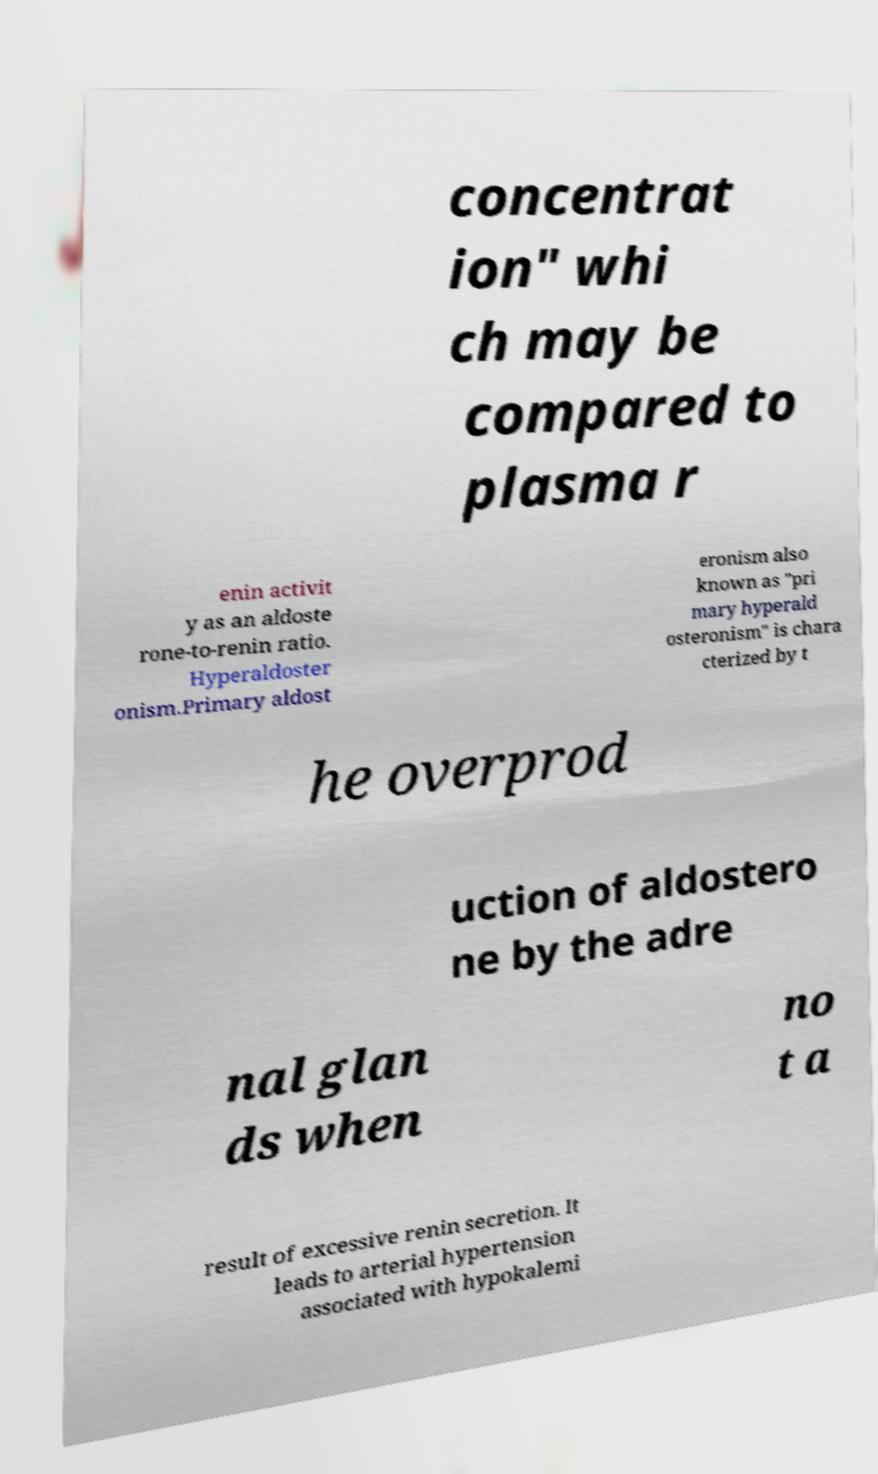Could you assist in decoding the text presented in this image and type it out clearly? concentrat ion" whi ch may be compared to plasma r enin activit y as an aldoste rone-to-renin ratio. Hyperaldoster onism.Primary aldost eronism also known as "pri mary hyperald osteronism" is chara cterized by t he overprod uction of aldostero ne by the adre nal glan ds when no t a result of excessive renin secretion. It leads to arterial hypertension associated with hypokalemi 